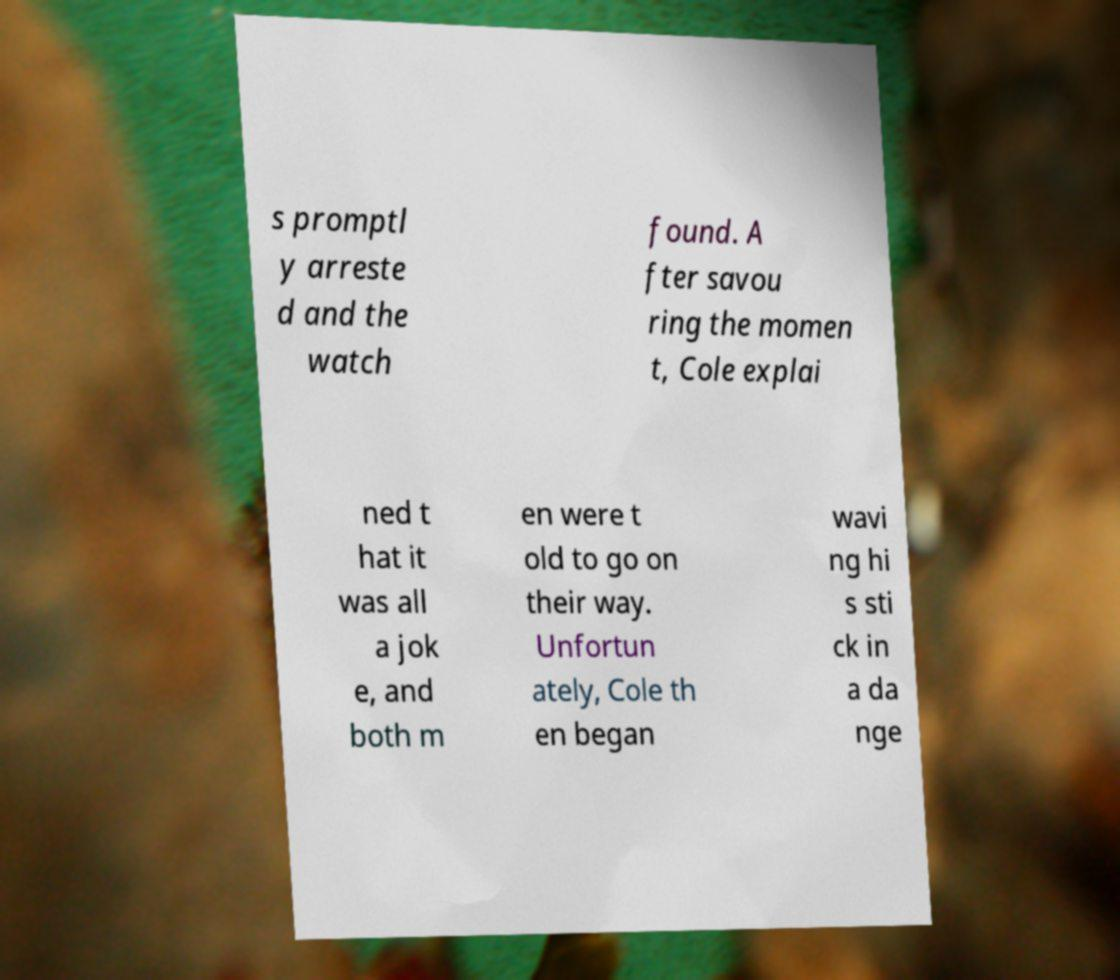Please identify and transcribe the text found in this image. s promptl y arreste d and the watch found. A fter savou ring the momen t, Cole explai ned t hat it was all a jok e, and both m en were t old to go on their way. Unfortun ately, Cole th en began wavi ng hi s sti ck in a da nge 